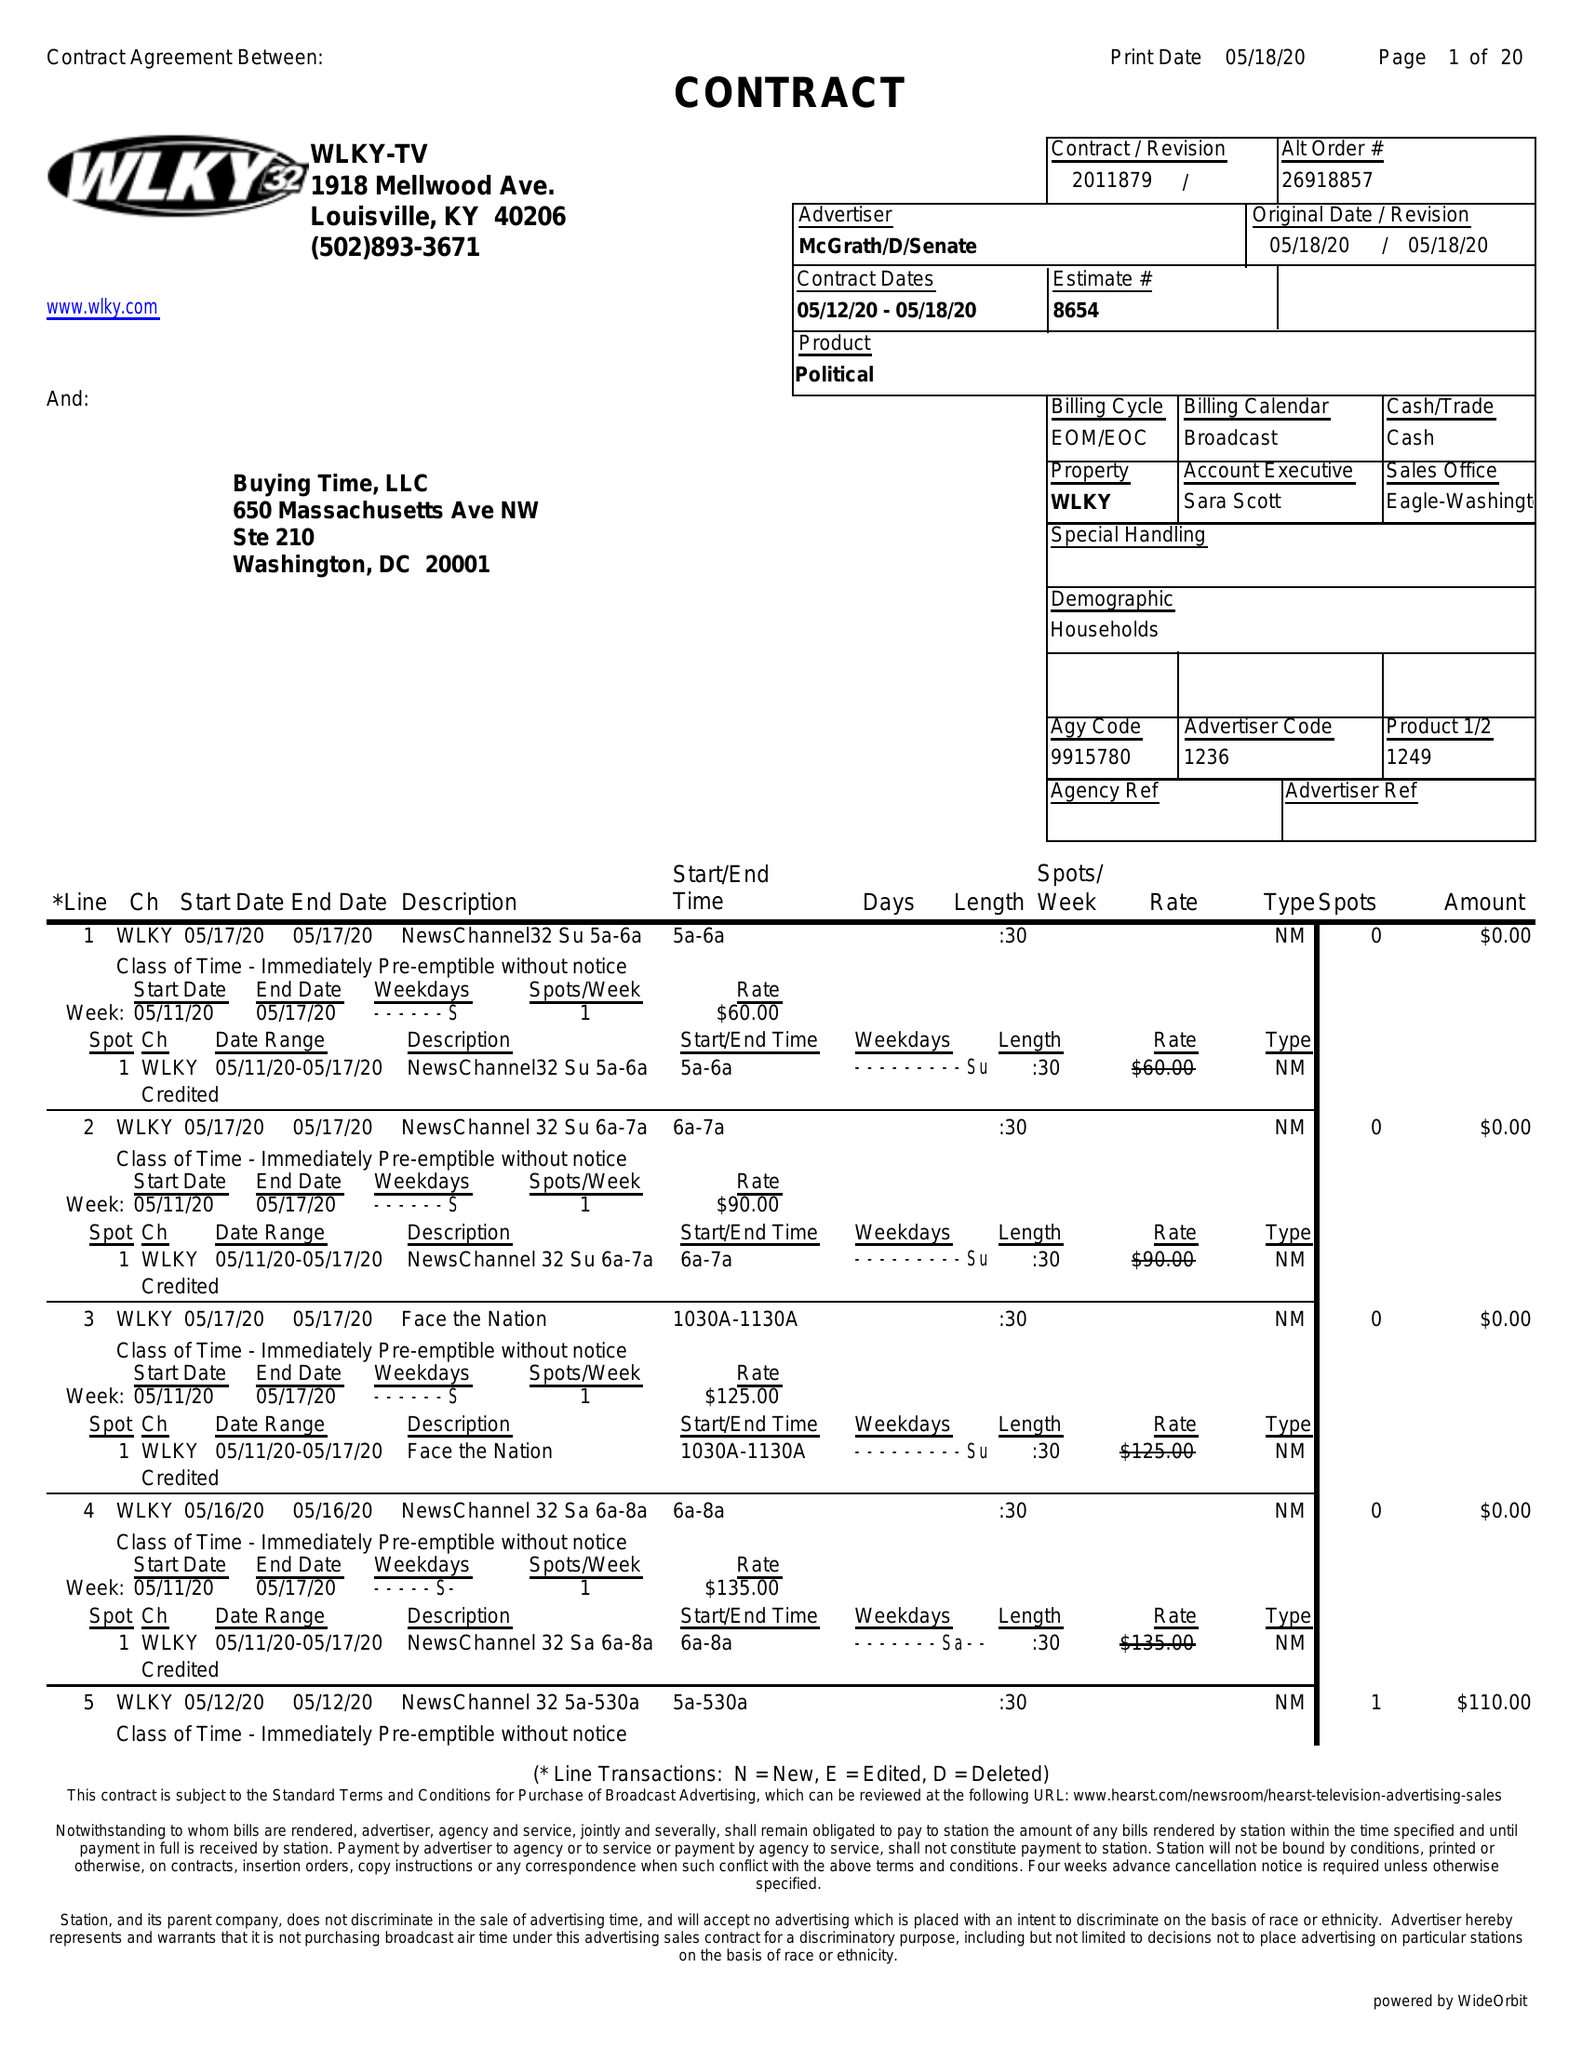What is the value for the flight_from?
Answer the question using a single word or phrase. 05/12/20 